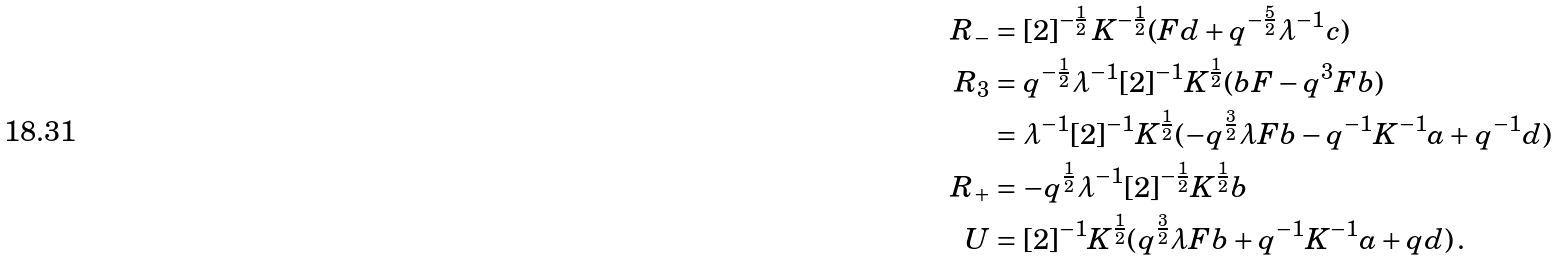<formula> <loc_0><loc_0><loc_500><loc_500>R _ { - } & = [ 2 ] ^ { - \frac { 1 } { 2 } } \, K ^ { - \frac { 1 } { 2 } } ( F d + q ^ { - \frac { 5 } { 2 } } \lambda ^ { - 1 } c ) \\ R _ { 3 } & = q ^ { - \frac { 1 } { 2 } } \lambda ^ { - 1 } [ 2 ] ^ { - 1 } K ^ { \frac { 1 } { 2 } } ( b F - q ^ { 3 } F b ) \\ & = \lambda ^ { - 1 } [ 2 ] ^ { - 1 } K ^ { \frac { 1 } { 2 } } ( - q ^ { \frac { 3 } { 2 } } \lambda F b - q ^ { - 1 } K ^ { - 1 } a + q ^ { - 1 } d ) \\ R _ { + } & = - q ^ { \frac { 1 } { 2 } } \lambda ^ { - 1 } [ 2 ] ^ { - \frac { 1 } { 2 } } K ^ { \frac { 1 } { 2 } } b \\ U & = [ 2 ] ^ { - 1 } K ^ { \frac { 1 } { 2 } } ( q ^ { \frac { 3 } { 2 } } \lambda F b + q ^ { - 1 } K ^ { - 1 } a + q d ) \, .</formula> 